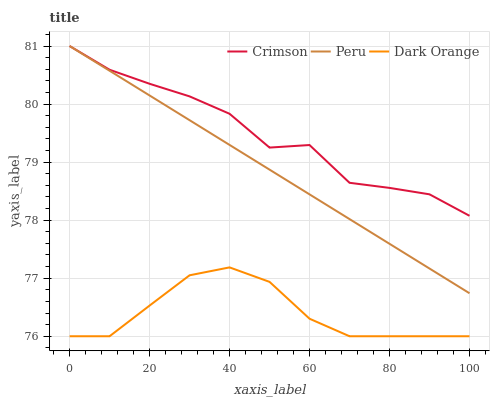Does Dark Orange have the minimum area under the curve?
Answer yes or no. Yes. Does Crimson have the maximum area under the curve?
Answer yes or no. Yes. Does Peru have the minimum area under the curve?
Answer yes or no. No. Does Peru have the maximum area under the curve?
Answer yes or no. No. Is Peru the smoothest?
Answer yes or no. Yes. Is Crimson the roughest?
Answer yes or no. Yes. Is Dark Orange the smoothest?
Answer yes or no. No. Is Dark Orange the roughest?
Answer yes or no. No. Does Dark Orange have the lowest value?
Answer yes or no. Yes. Does Peru have the lowest value?
Answer yes or no. No. Does Peru have the highest value?
Answer yes or no. Yes. Does Dark Orange have the highest value?
Answer yes or no. No. Is Dark Orange less than Crimson?
Answer yes or no. Yes. Is Crimson greater than Dark Orange?
Answer yes or no. Yes. Does Crimson intersect Peru?
Answer yes or no. Yes. Is Crimson less than Peru?
Answer yes or no. No. Is Crimson greater than Peru?
Answer yes or no. No. Does Dark Orange intersect Crimson?
Answer yes or no. No. 